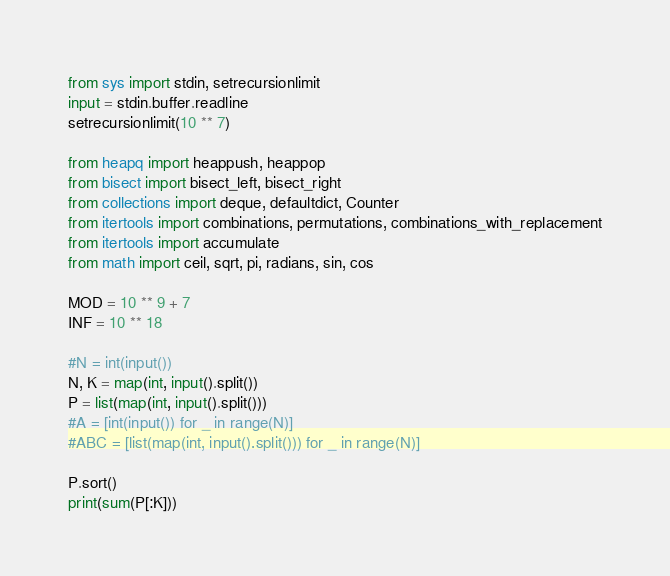<code> <loc_0><loc_0><loc_500><loc_500><_Python_>from sys import stdin, setrecursionlimit
input = stdin.buffer.readline
setrecursionlimit(10 ** 7)

from heapq import heappush, heappop
from bisect import bisect_left, bisect_right
from collections import deque, defaultdict, Counter
from itertools import combinations, permutations, combinations_with_replacement
from itertools import accumulate
from math import ceil, sqrt, pi, radians, sin, cos

MOD = 10 ** 9 + 7
INF = 10 ** 18

#N = int(input())
N, K = map(int, input().split())
P = list(map(int, input().split()))
#A = [int(input()) for _ in range(N)]
#ABC = [list(map(int, input().split())) for _ in range(N)]

P.sort()
print(sum(P[:K]))</code> 